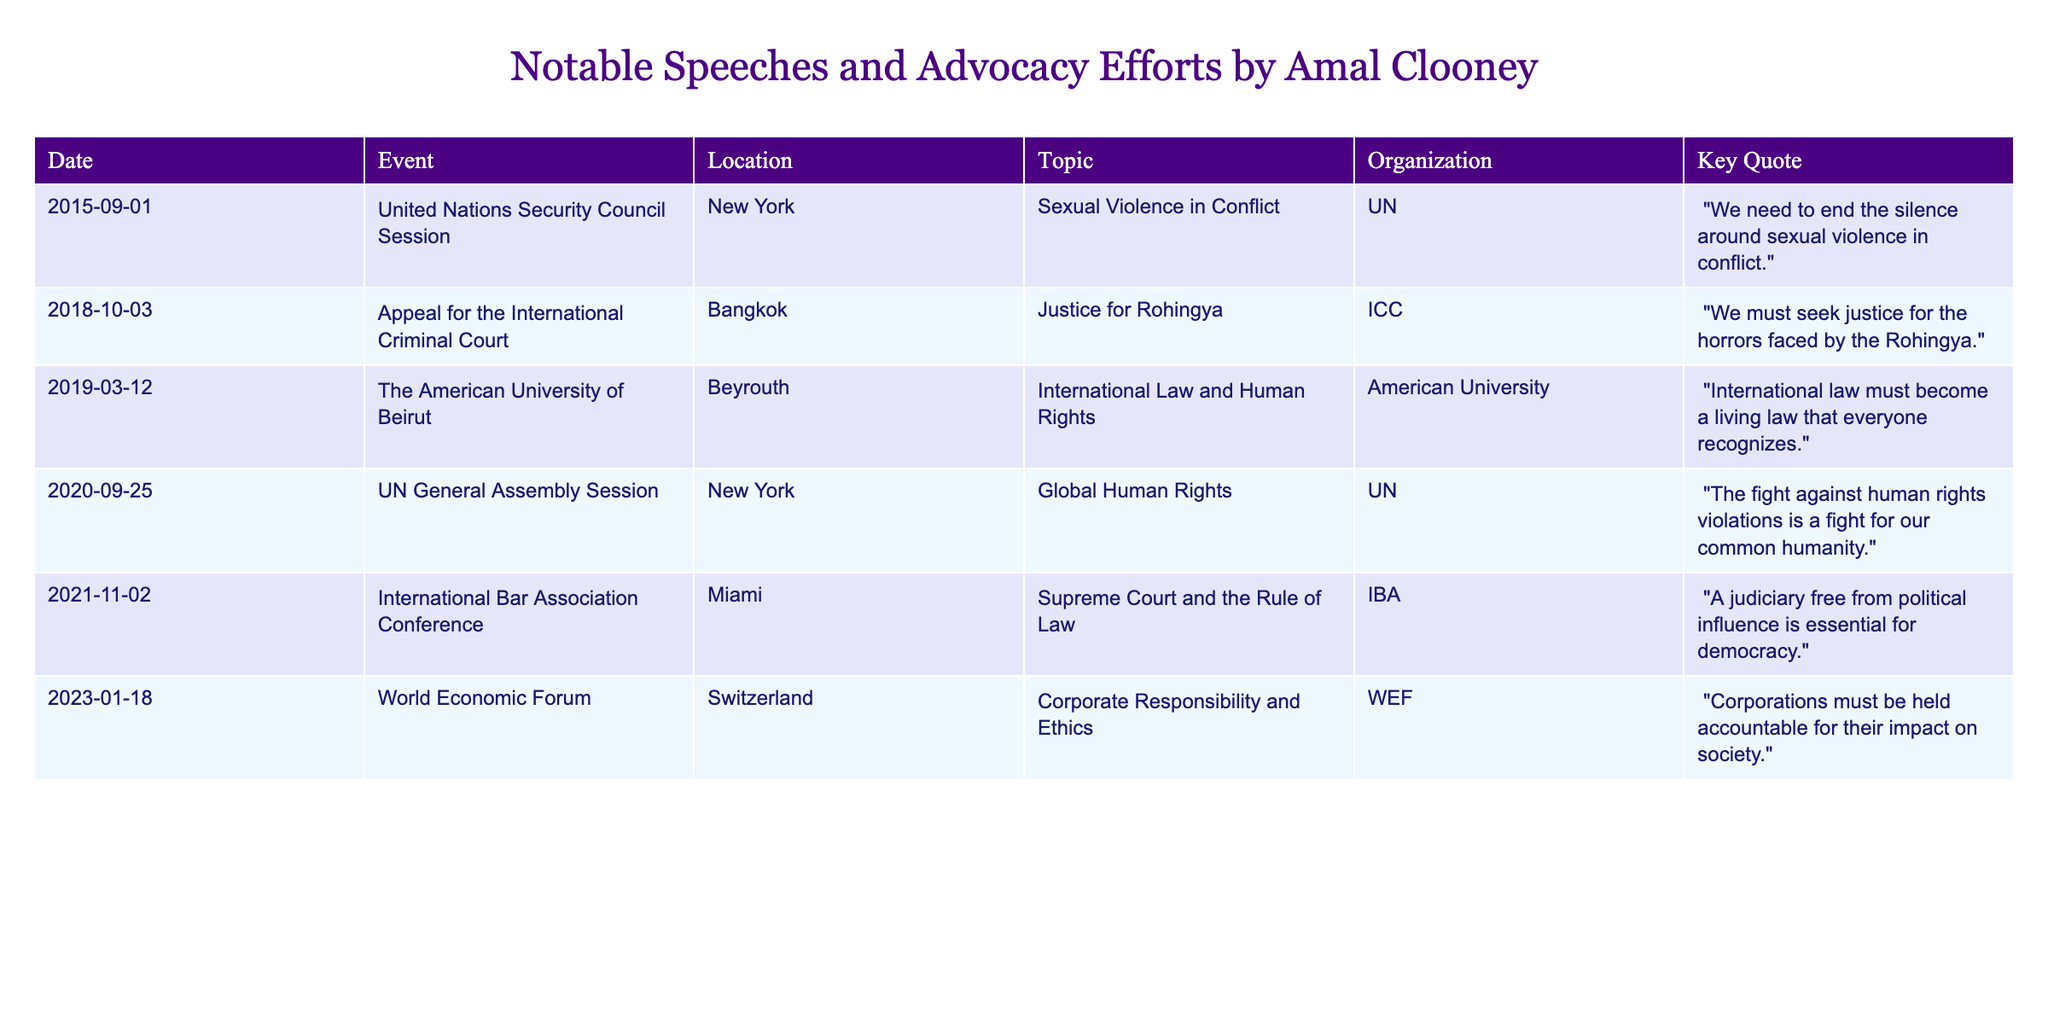What was the topic of Amal Clooney's speech at the UN General Assembly in 2020? The table indicates that the topic of her speech at the UN General Assembly on September 25, 2020, was "Global Human Rights."
Answer: Global Human Rights Which organization did Amal Clooney speak for at the International Criminal Court in 2018? According to the table, Amal Clooney spoke for the International Criminal Court (ICC) at the event in 2018.
Answer: ICC How many speeches addressed issues related to human rights? In the table, the speeches at the United Nations Security Council Session (2015), the UN General Assembly Session (2020), and the speech at the American University of Beirut (2019) are all about human rights, totaling three speeches.
Answer: 3 What is the key quote from Amal Clooney's speech in 2015? The key quote listed in the table for the speech in 2015 is, "We need to end the silence around sexual violence in conflict."
Answer: "We need to end the silence around sexual violence in conflict." Which event featured a focus on corporate responsibility and ethics? The table shows that the World Economic Forum in Switzerland on January 18, 2023, highlighted corporate responsibility and ethics as its focus.
Answer: World Economic Forum Do any of the events listed take place in New York? The table lists two events taking place in New York: the United Nations Security Council Session in 2015 and the UN General Assembly Session in 2020.
Answer: Yes What is the latest event listed in the table? By reviewing the dates in the table, the latest event listed is on January 18, 2023, at the World Economic Forum in Switzerland.
Answer: World Economic Forum How many different locations are mentioned in the table? The table indicates five different locations: New York, Bangkok, Beyrouth, Miami, and Switzerland, totaling five distinct locations.
Answer: 5 What was the key message of Amal Clooney's speech at the International Bar Association Conference? The table states that the key message from her speech at the International Bar Association Conference was, "A judiciary free from political influence is essential for democracy."
Answer: "A judiciary free from political influence is essential for democracy." Which event or speech focused specifically on the topic of justice for Rohingya? The table specifies that the appeal for the International Criminal Court in Bangkok on October 3, 2018, focused specifically on justice for Rohingya.
Answer: Appeal for the International Criminal Court How many speeches did Amal Clooney give on the topic of sexual violence? The table indicates that there is one speech on the topic of sexual violence, which was given during the United Nations Security Council Session in 2015.
Answer: 1 